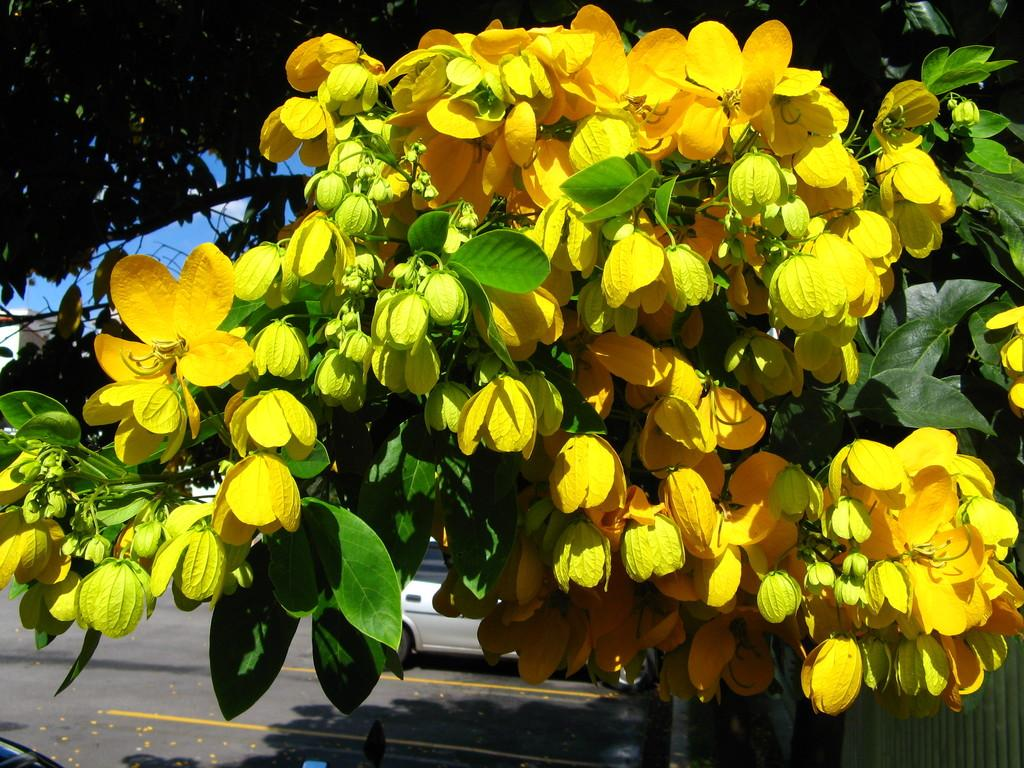What type of plants can be seen in the image? There are flowers and leaves in the image. What else is visible in the image besides plants? There is a car on the road in the image. What can be seen in the background of the image? The sky is visible in the background of the image, and there are clouds in the sky. What type of machine is being used to roll down the slope in the image? There is no machine or slope present in the image. 